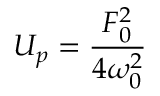Convert formula to latex. <formula><loc_0><loc_0><loc_500><loc_500>U _ { p } = \frac { F _ { 0 } ^ { 2 } } { 4 \omega _ { 0 } ^ { 2 } }</formula> 